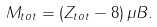Convert formula to latex. <formula><loc_0><loc_0><loc_500><loc_500>M _ { t o t } = ( Z _ { t o t } - 8 ) \, \mu B .</formula> 